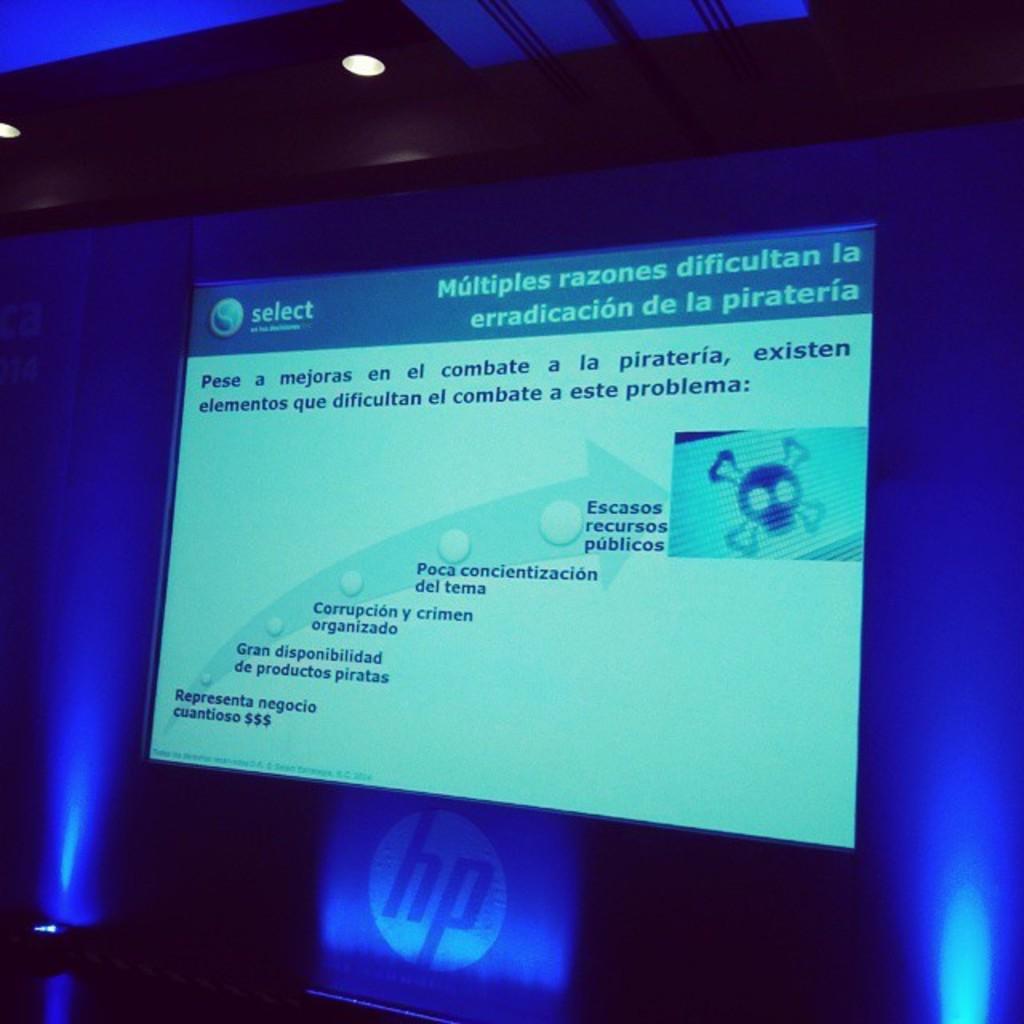What computer company is shown below the screen?
Provide a succinct answer. Hp. What information in the picture?
Your answer should be very brief. Eradicating piracy. 